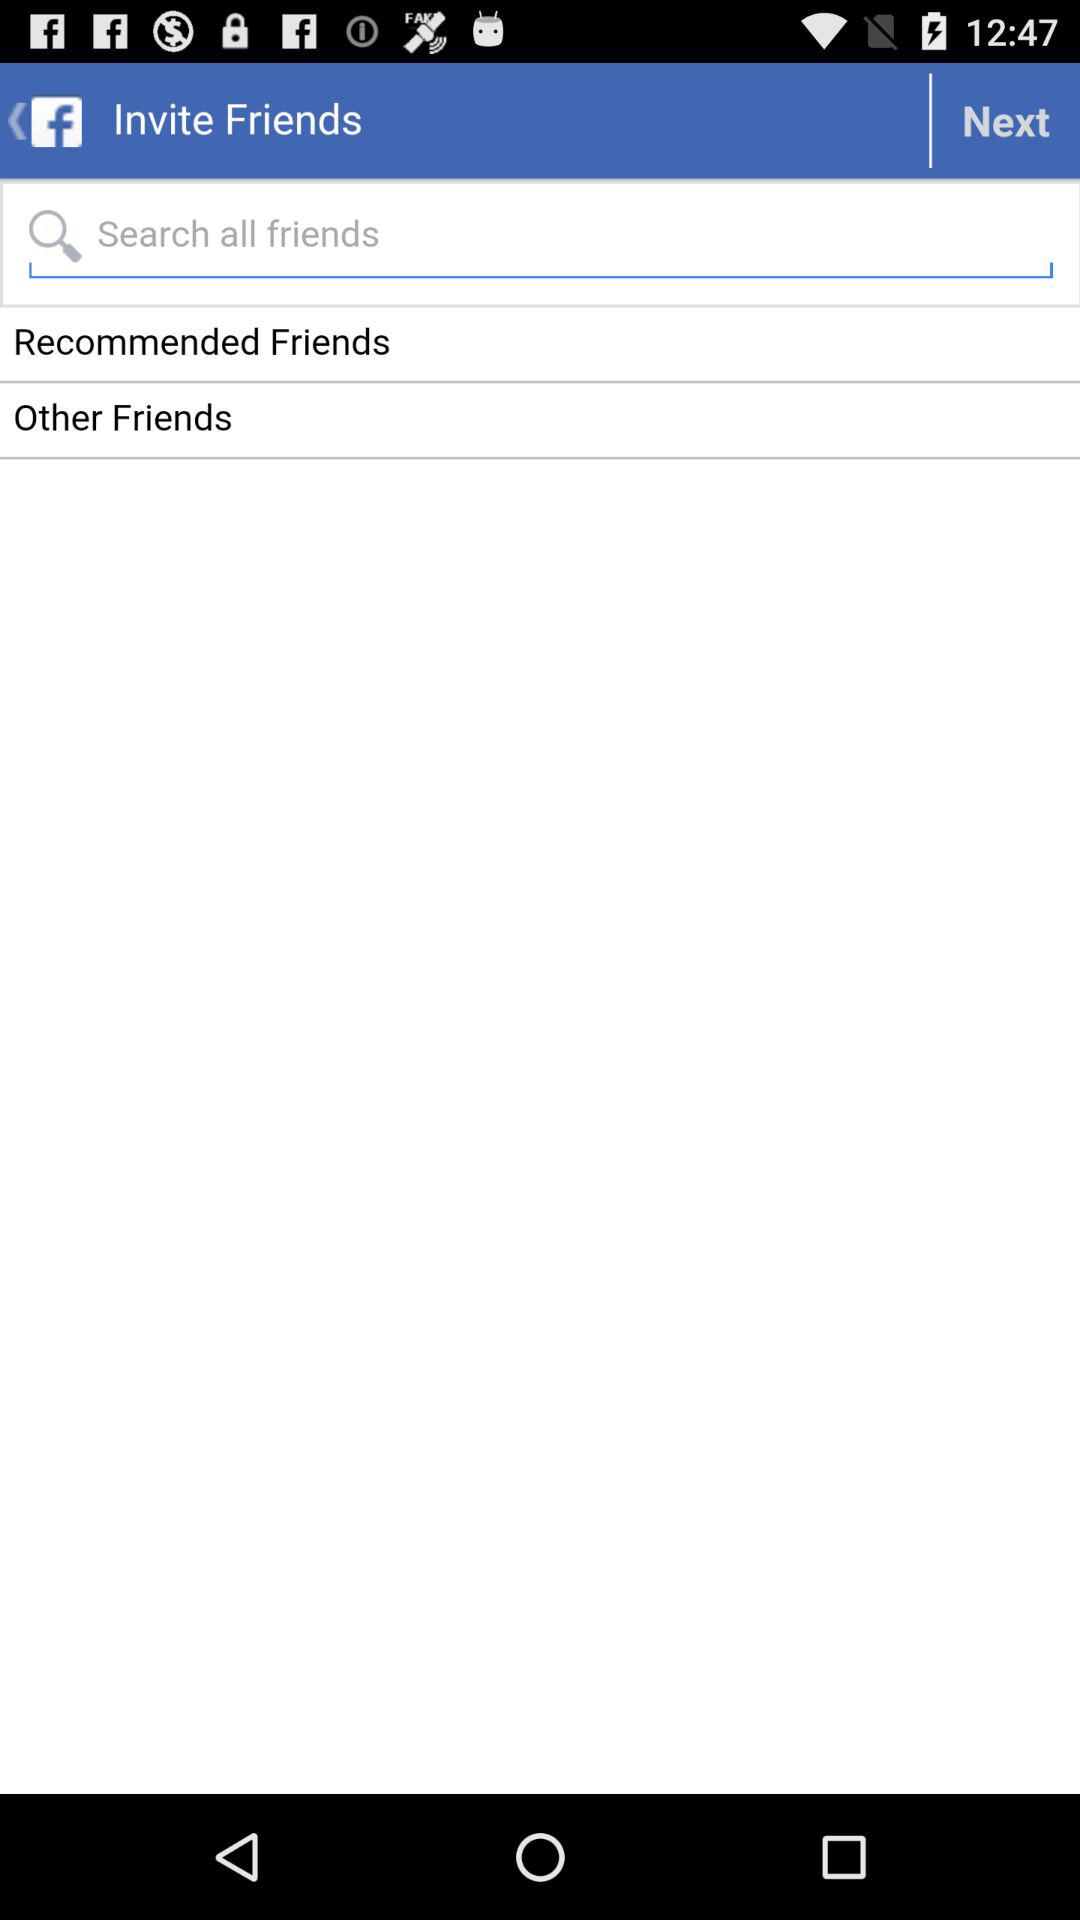What application can be used to log in to the profile? To log in to the profile, "Facebook" can be used. 